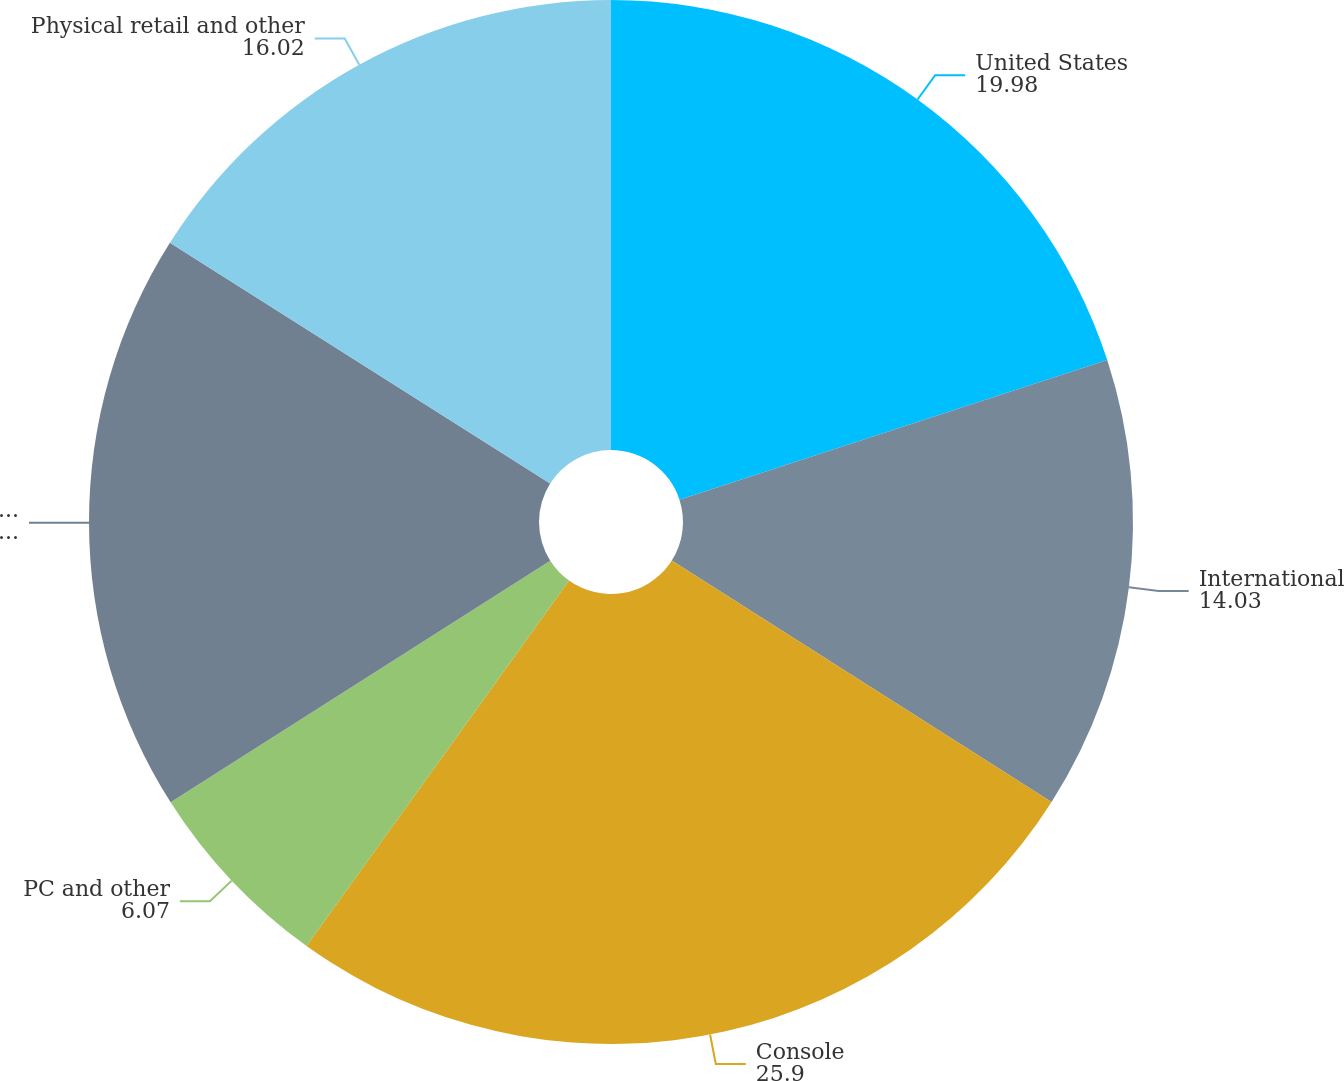Convert chart to OTSL. <chart><loc_0><loc_0><loc_500><loc_500><pie_chart><fcel>United States<fcel>International<fcel>Console<fcel>PC and other<fcel>Digital online<fcel>Physical retail and other<nl><fcel>19.98%<fcel>14.03%<fcel>25.9%<fcel>6.07%<fcel>18.0%<fcel>16.02%<nl></chart> 